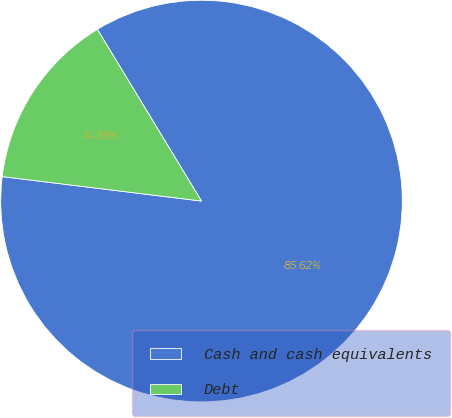Convert chart. <chart><loc_0><loc_0><loc_500><loc_500><pie_chart><fcel>Cash and cash equivalents<fcel>Debt<nl><fcel>85.62%<fcel>14.38%<nl></chart> 